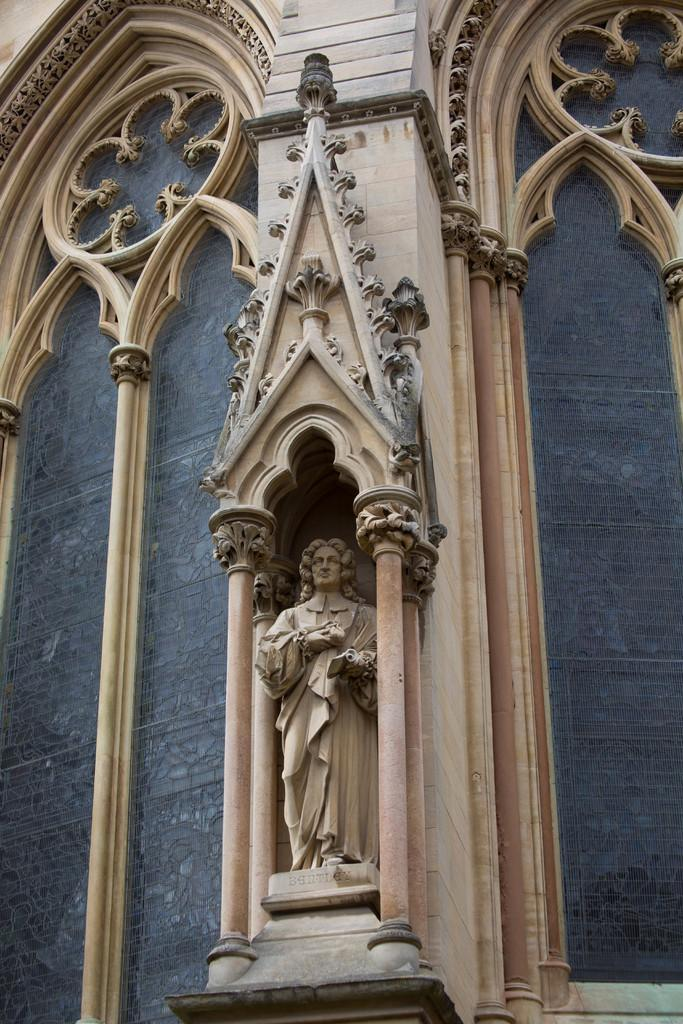What type of structure is present in the image? There is a building in the image. What additional feature can be seen in the image? There is a statue structure in the image. What material is visible on the right side of the image? There is glass visible on the right side of the image. What material is visible on the left side of the image? There is glass visible on the left side of the image. How many people are sleeping in the image? There is no indication of anyone sleeping in the image. What type of curve can be seen in the image? There is no curve visible in the image. 